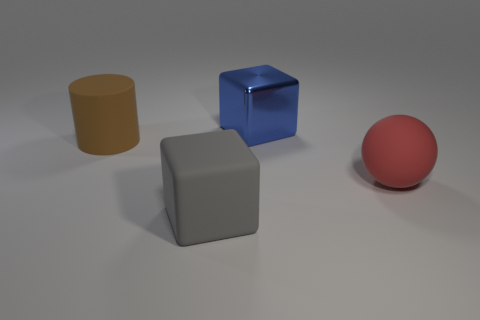How many big objects are either green metal spheres or brown matte things?
Provide a short and direct response. 1. How many big cylinders are to the right of the red rubber ball?
Give a very brief answer. 0. Is there a big matte thing that has the same color as the large metal thing?
Ensure brevity in your answer.  No. What shape is the gray object that is the same size as the blue shiny thing?
Give a very brief answer. Cube. How many purple objects are either objects or big matte objects?
Your answer should be very brief. 0. How many red things have the same size as the brown cylinder?
Provide a succinct answer. 1. How many things are big red spheres or red matte spheres in front of the big cylinder?
Offer a very short reply. 1. There is a block that is in front of the blue thing; is its size the same as the thing that is behind the large brown rubber object?
Offer a very short reply. Yes. What number of large red rubber things are the same shape as the brown thing?
Provide a succinct answer. 0. There is a brown object that is the same material as the gray cube; what shape is it?
Offer a terse response. Cylinder. 